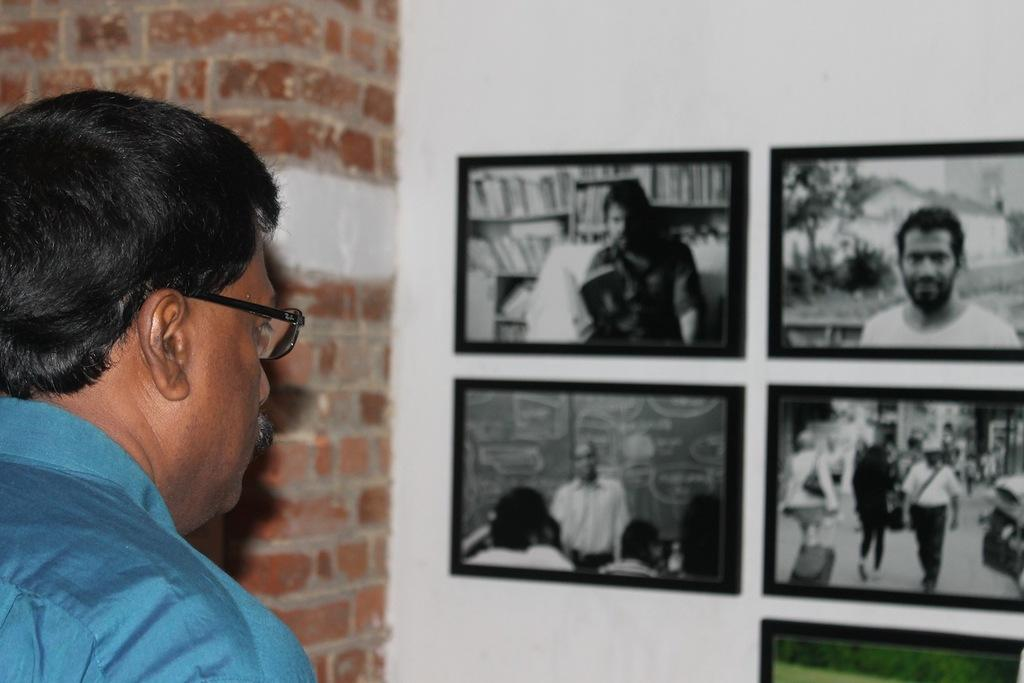Who is present in the image? There is a man in the image. What is the man wearing? The man is wearing a blue shirt. Are there any accessories visible on the man? Yes, the man is wearing glasses. Where is the man positioned in the image? The man is standing on the left side of the image. What can be seen on the wall in the image? There are many photo frames on the wall in the image. What is the sun doing in the image? There is no sun present in the image; it is an indoor setting. How does the man's tongue look like in the image? The man's tongue is not visible in the image. 